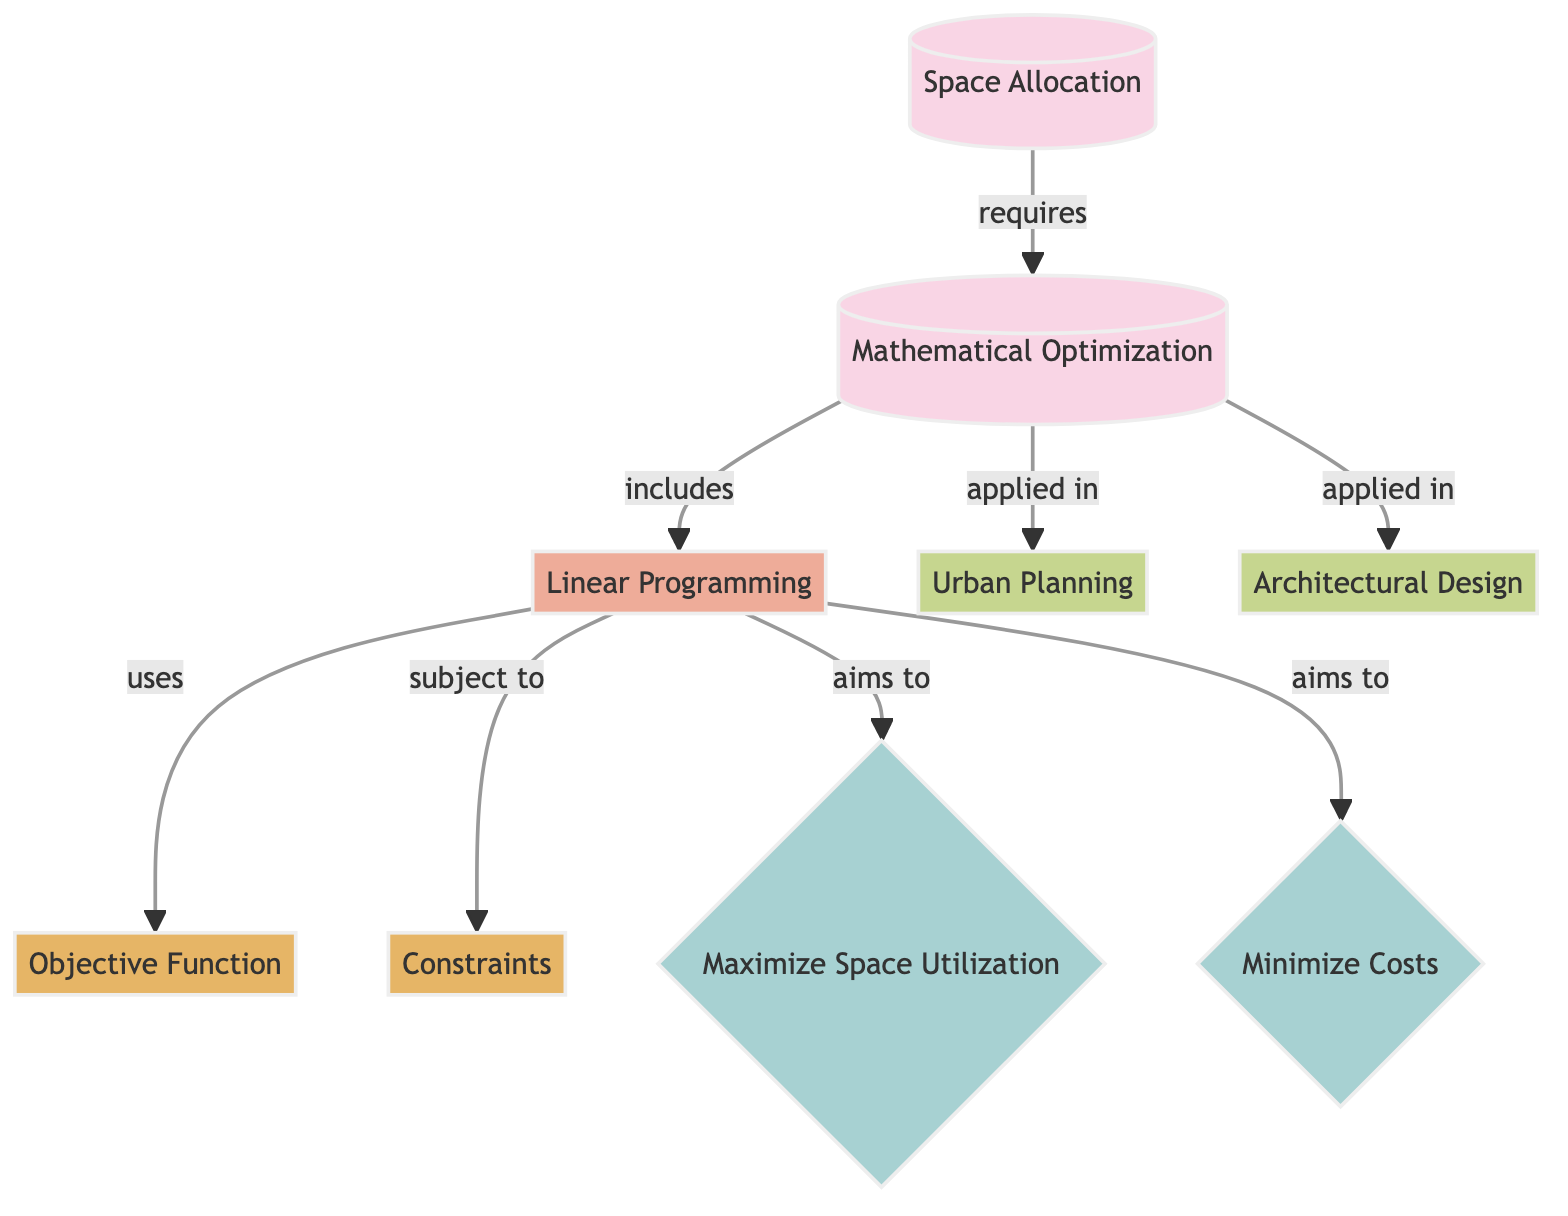What's the main goal of Linear Programming? The diagram indicates that Linear Programming aims to maximize space utilization and minimize costs, both of which are highlighted as goals connected to the Linear Programming node.
Answer: Maximize space utilization and minimize costs How many applications are shown in the diagram? Two applications are depicted in the diagram, specifically Urban Planning and Architectural Design, which are directly connected to the Mathematical Optimization node.
Answer: 2 What type of technique is Linear Programming classified as? According to the diagram, Linear Programming falls under the category of techniques, as shown by its classification in the flowchart.
Answer: Technique What is subject to the Linear Programming? The diagram shows that Linear Programming is subject to a set of constraints, which is indicated by the directed edge from the Linear Programming node to the Constraints node.
Answer: Constraints Which concept is required for Space Allocation? The diagram specifies that Space Allocation requires Mathematical Optimization, demonstrated by the connection from the Space Allocation node to the Mathematical Optimization node.
Answer: Mathematical Optimization What is the relationship between Mathematical Optimization and its applications? The diagram illustrates that Mathematical Optimization is applied in both Urban Planning and Architectural Design, clearly indicating a connection between the two components.
Answer: Applied in Urban Planning and Architectural Design List one goal associated with Linear Programming. The diagram identifies two goals associated with Linear Programming, one of which is "Maximize Space Utilization." This is a direct connection from the Linear Programming node to the goal node.
Answer: Maximize Space Utilization How many components are part of the Linear Programming technique? The diagram shows that there are two components associated with Linear Programming, specifically the Objective Function and Constraints, each represented as connected nodes.
Answer: 2 What does Space Allocation require according to the diagram? Space Allocation requires Mathematical Optimization, as indicated by the directed edge between the Space Allocation node and the Mathematical Optimization node.
Answer: Mathematical Optimization 